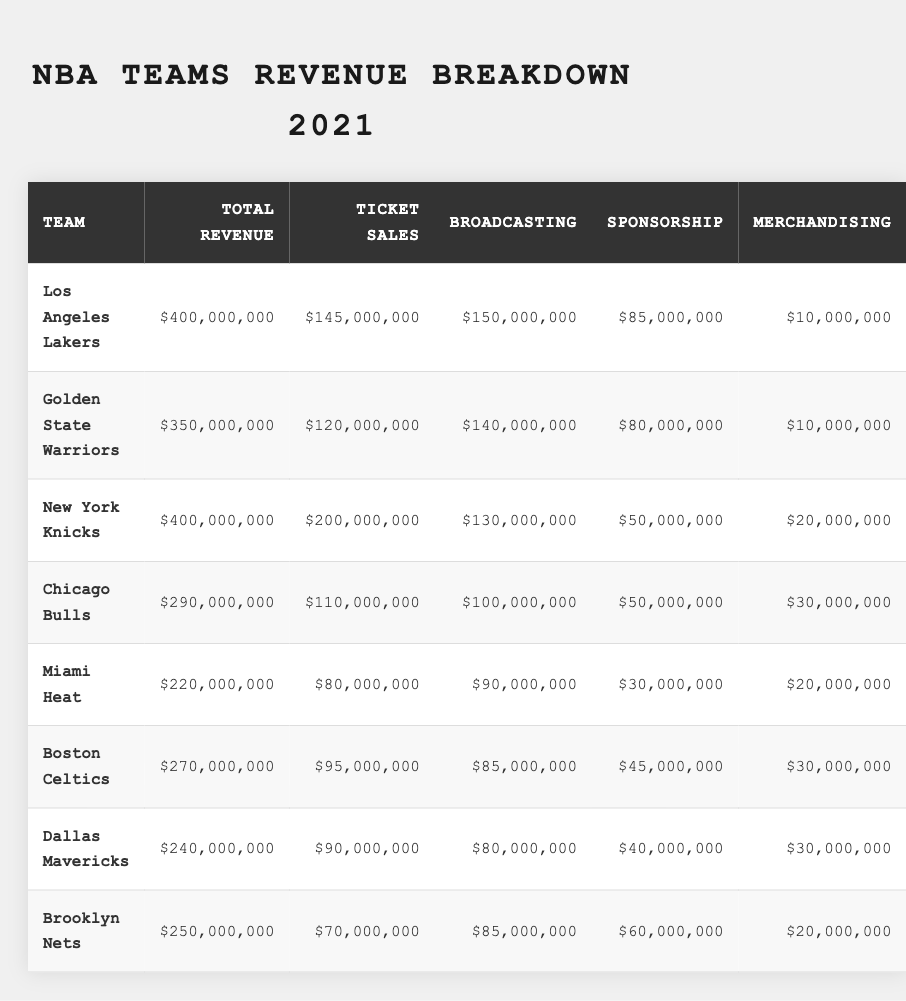What is the total revenue for the New York Knicks? The table shows the New York Knicks' total revenue listed as $400,000,000.
Answer: $400,000,000 Which team has the highest ticket sales? By looking at the ticket sales column, the New York Knicks have the highest ticket sales of $200,000,000.
Answer: New York Knicks How much revenue did the Miami Heat generate from broadcasting? The Miami Heat generated $90,000,000 from broadcasting as indicated in the table.
Answer: $90,000,000 What is the total revenue of the Chicago Bulls and the Dallas Mavericks combined? The total revenue for the Chicago Bulls is $290,000,000 and for the Dallas Mavericks is $240,000,000. Adding them gives $290,000,000 + $240,000,000 = $530,000,000.
Answer: $530,000,000 Is the total revenue for the Golden State Warriors greater than that of the Miami Heat? The Golden State Warriors' total revenue is $350,000,000, while the Miami Heat's is $220,000,000. Since $350,000,000 is greater than $220,000,000, the statement is true.
Answer: Yes What percentage of total revenue do the ticket sales represent for the Los Angeles Lakers? The Los Angeles Lakers' ticket sales are $145,000,000 out of total revenue of $400,000,000. To find the percentage: (145,000,000 / 400,000,000) * 100 = 36.25%.
Answer: 36.25% How much more revenue is generated from broadcasting by the Golden State Warriors compared to the Brooklyn Nets? The Golden State Warriors earn $140,000,000 from broadcasting, while the Brooklyn Nets earn $85,000,000. The difference is $140,000,000 - $85,000,000 = $55,000,000.
Answer: $55,000,000 If the Dallas Mavericks' merchandising revenue increased by $10,000,000, what would their total revenue be? The current total revenue of the Dallas Mavericks is $240,000,000. Adding the increased merchandising revenue: $240,000,000 + $10,000,000 = $250,000,000.
Answer: $250,000,000 What is the average total revenue of all the teams listed? To find the average, sum the total revenues: $400,000,000 + $350,000,000 + $400,000,000 + $290,000,000 + $220,000,000 + $270,000,000 + $240,000,000 + $250,000,000 = $2,420,000,000. There are 8 teams, so the average is $2,420,000,000 / 8 = $302,500,000.
Answer: $302,500,000 Which team has the greatest revenue from sponsorship? The table indicates that the Los Angeles Lakers have the greatest revenue from sponsorship with $85,000,000.
Answer: Los Angeles Lakers 